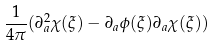Convert formula to latex. <formula><loc_0><loc_0><loc_500><loc_500>\frac { 1 } { 4 \pi } ( \partial _ { a } ^ { 2 } \chi ( \xi ) - \partial _ { a } \phi ( \xi ) \partial _ { a } \chi ( \xi ) )</formula> 